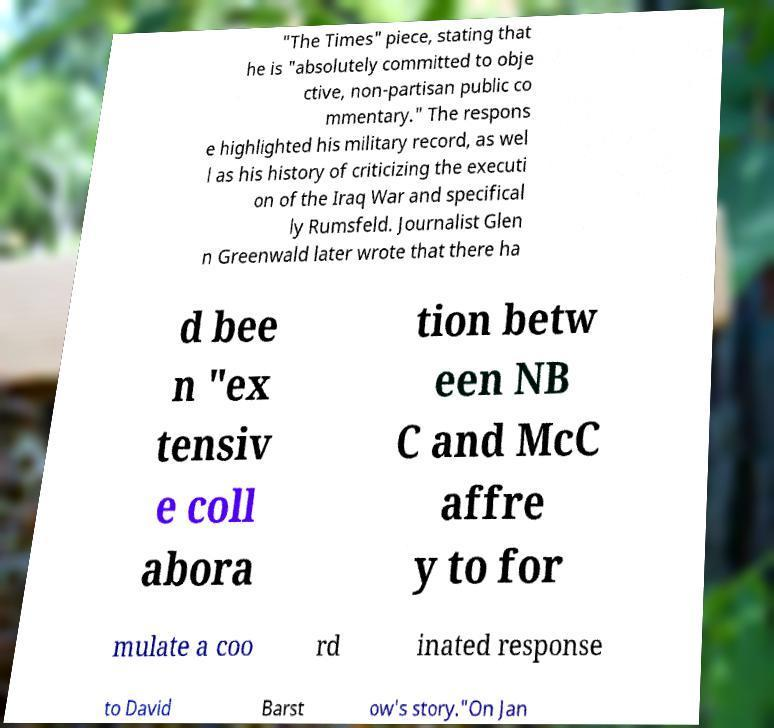I need the written content from this picture converted into text. Can you do that? "The Times" piece, stating that he is "absolutely committed to obje ctive, non-partisan public co mmentary." The respons e highlighted his military record, as wel l as his history of criticizing the executi on of the Iraq War and specifical ly Rumsfeld. Journalist Glen n Greenwald later wrote that there ha d bee n "ex tensiv e coll abora tion betw een NB C and McC affre y to for mulate a coo rd inated response to David Barst ow's story."On Jan 